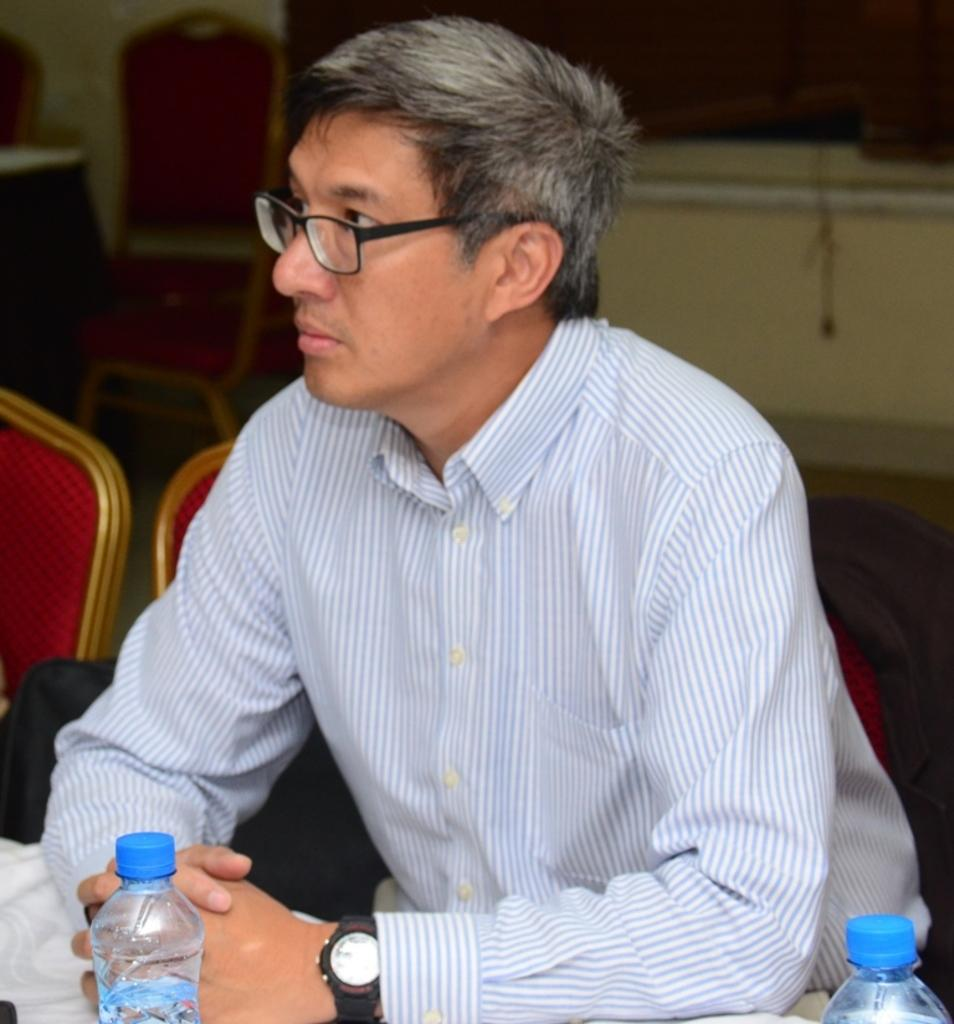What is the person in the image doing? The person is sitting on a chair in the image. What is the person looking at? The person is looking at something, but we cannot determine what it is from the image. What is on the table in front of the person? There is a water bottle on the table. What type of house is being attacked by the person in the image? There is no house or attack present in the image; it only shows a person sitting on a chair and looking at something. 